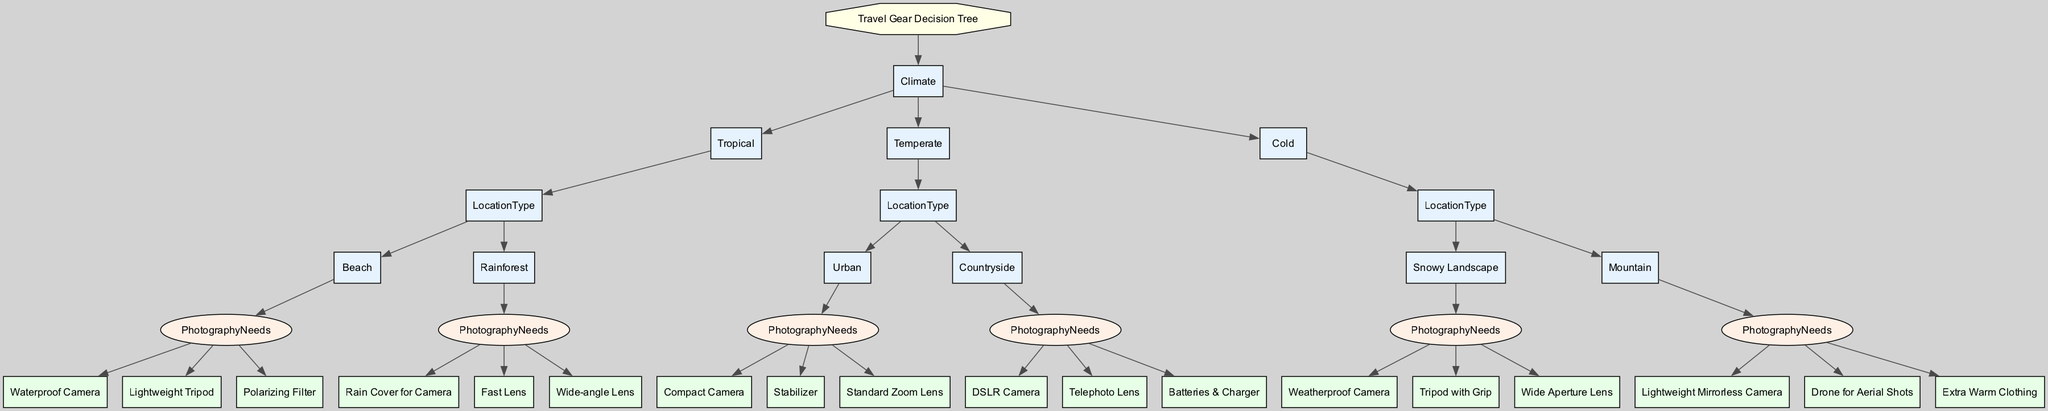What type of photography gear is recommended for a tropical rainforest? The decision tree specifies that if the climate is tropical and the location type is rainforest, then the recommended photography gear includes a rain cover for the camera, a fast lens, and a wide-angle lens.
Answer: Rain Cover for Camera, Fast Lens, Wide-angle Lens How many types of locations are mentioned for temperate climates? In the temperate climate section, there are two location types mentioned: urban and countryside. Therefore, the total count of location types is two.
Answer: 2 What gear should one consider for a cold snowy landscape? According to the tree, for a cold snowy landscape, the recommended photography gear consists of a weatherproof camera, a tripod with grip, and a wide aperture lens.
Answer: Weatherproof Camera, Tripod with Grip, Wide Aperture Lens If I am traveling to a tropical beach, how many different types of photography needs should I prepare for? The tree indicates that there are three listed photography needs for the tropical beach, which are waterproof camera, lightweight tripod, and polarizing filter. Thus, the count is three.
Answer: 3 Which camera is recommended for a countryside location in a temperate climate? The diagram specifies that for a countryside location in a temperate climate, a DSLR camera is recommended along with a telephoto lens and batteries & charger.
Answer: DSLR Camera What is the primary lens suggested for capturing aerial shots in mountainous areas? The recommended gear for photographing in mountainous areas includes a drone for aerial shots as one of the key items.
Answer: Drone for Aerial Shots How many photography needs are listed under the urban location type? Under the urban location type in the temperate climate section, there are three photography needs provided: a compact camera, stabilizer, and standard zoom lens. Therefore, the total is three.
Answer: 3 What camera type is indicated for snowy landscapes? The diagram mentions a weatherproof camera as the recommended type of camera specifically for snowy landscapes under cold climate conditions.
Answer: Weatherproof Camera Which type of filter is recommended for tropical beaches? The travel gear decision tree recommends using a polarizing filter for capturing images at tropical beaches.
Answer: Polarizing Filter 